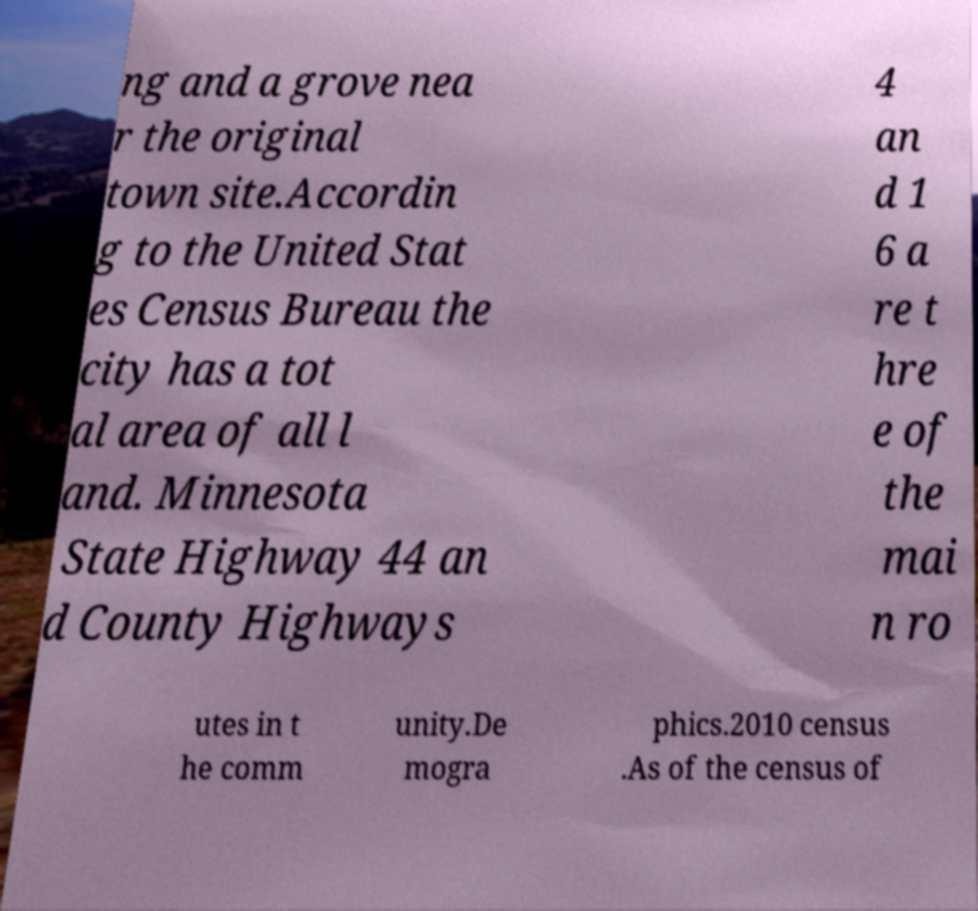Please read and relay the text visible in this image. What does it say? ng and a grove nea r the original town site.Accordin g to the United Stat es Census Bureau the city has a tot al area of all l and. Minnesota State Highway 44 an d County Highways 4 an d 1 6 a re t hre e of the mai n ro utes in t he comm unity.De mogra phics.2010 census .As of the census of 